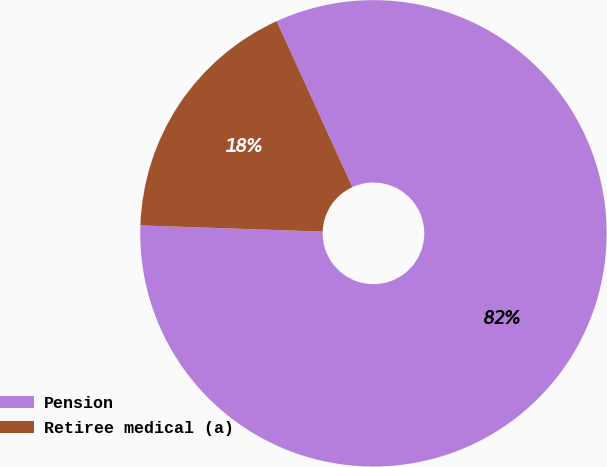Convert chart to OTSL. <chart><loc_0><loc_0><loc_500><loc_500><pie_chart><fcel>Pension<fcel>Retiree medical (a)<nl><fcel>82.35%<fcel>17.65%<nl></chart> 